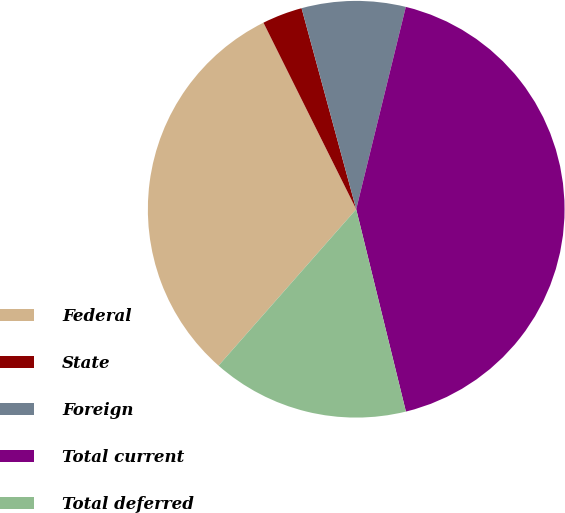<chart> <loc_0><loc_0><loc_500><loc_500><pie_chart><fcel>Federal<fcel>State<fcel>Foreign<fcel>Total current<fcel>Total deferred<nl><fcel>31.17%<fcel>3.12%<fcel>8.05%<fcel>42.34%<fcel>15.32%<nl></chart> 